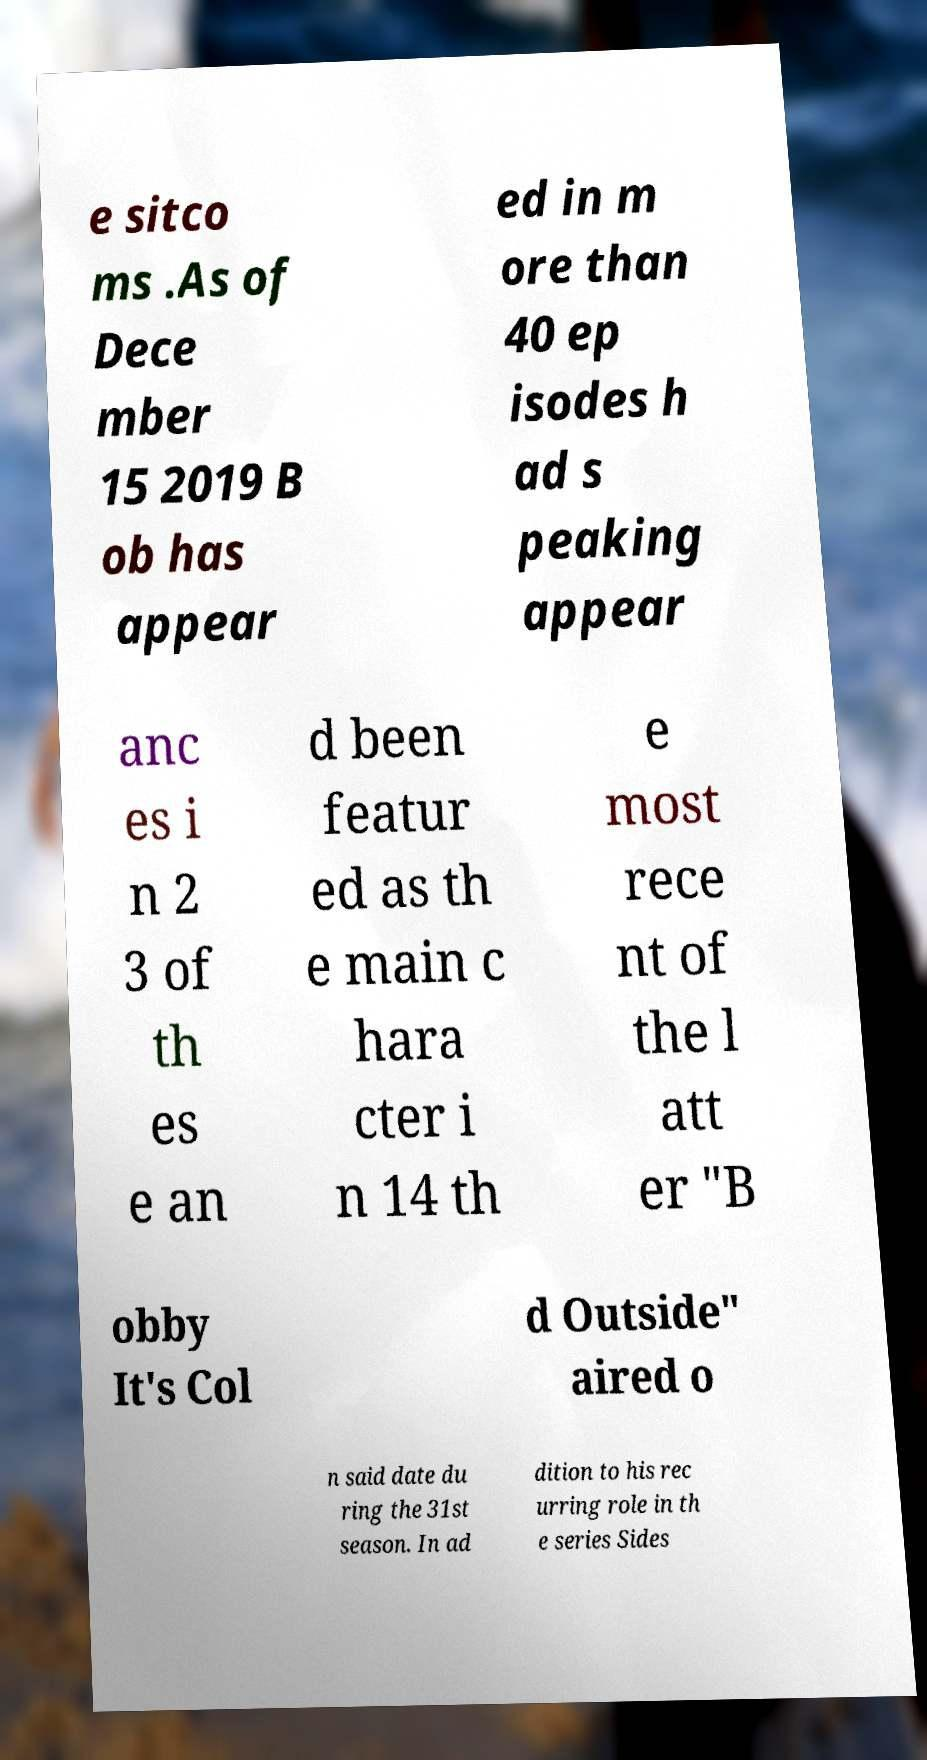Can you read and provide the text displayed in the image?This photo seems to have some interesting text. Can you extract and type it out for me? e sitco ms .As of Dece mber 15 2019 B ob has appear ed in m ore than 40 ep isodes h ad s peaking appear anc es i n 2 3 of th es e an d been featur ed as th e main c hara cter i n 14 th e most rece nt of the l att er "B obby It's Col d Outside" aired o n said date du ring the 31st season. In ad dition to his rec urring role in th e series Sides 